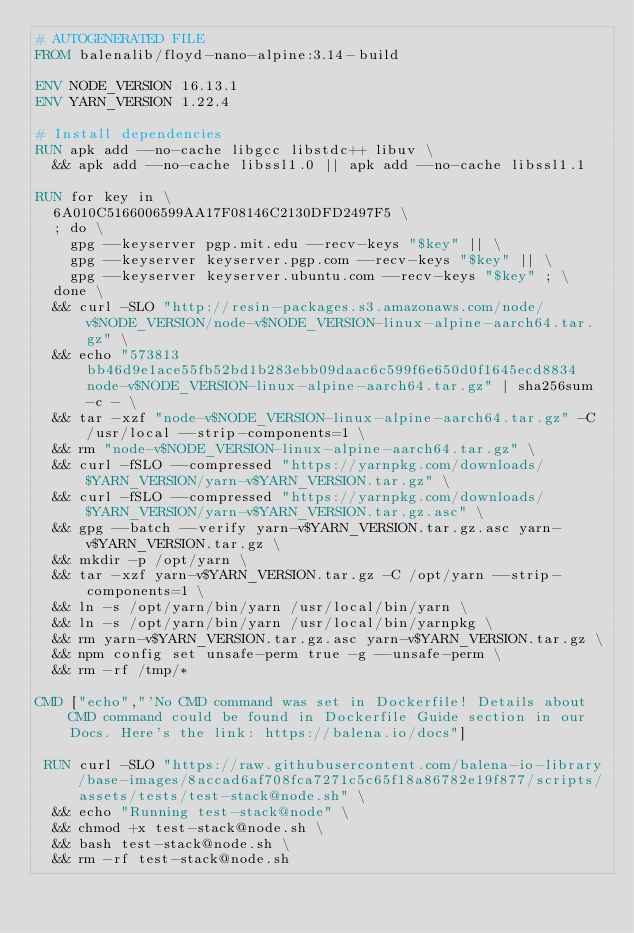<code> <loc_0><loc_0><loc_500><loc_500><_Dockerfile_># AUTOGENERATED FILE
FROM balenalib/floyd-nano-alpine:3.14-build

ENV NODE_VERSION 16.13.1
ENV YARN_VERSION 1.22.4

# Install dependencies
RUN apk add --no-cache libgcc libstdc++ libuv \
	&& apk add --no-cache libssl1.0 || apk add --no-cache libssl1.1

RUN for key in \
	6A010C5166006599AA17F08146C2130DFD2497F5 \
	; do \
		gpg --keyserver pgp.mit.edu --recv-keys "$key" || \
		gpg --keyserver keyserver.pgp.com --recv-keys "$key" || \
		gpg --keyserver keyserver.ubuntu.com --recv-keys "$key" ; \
	done \
	&& curl -SLO "http://resin-packages.s3.amazonaws.com/node/v$NODE_VERSION/node-v$NODE_VERSION-linux-alpine-aarch64.tar.gz" \
	&& echo "573813bb46d9e1ace55fb52bd1b283ebb09daac6c599f6e650d0f1645ecd8834  node-v$NODE_VERSION-linux-alpine-aarch64.tar.gz" | sha256sum -c - \
	&& tar -xzf "node-v$NODE_VERSION-linux-alpine-aarch64.tar.gz" -C /usr/local --strip-components=1 \
	&& rm "node-v$NODE_VERSION-linux-alpine-aarch64.tar.gz" \
	&& curl -fSLO --compressed "https://yarnpkg.com/downloads/$YARN_VERSION/yarn-v$YARN_VERSION.tar.gz" \
	&& curl -fSLO --compressed "https://yarnpkg.com/downloads/$YARN_VERSION/yarn-v$YARN_VERSION.tar.gz.asc" \
	&& gpg --batch --verify yarn-v$YARN_VERSION.tar.gz.asc yarn-v$YARN_VERSION.tar.gz \
	&& mkdir -p /opt/yarn \
	&& tar -xzf yarn-v$YARN_VERSION.tar.gz -C /opt/yarn --strip-components=1 \
	&& ln -s /opt/yarn/bin/yarn /usr/local/bin/yarn \
	&& ln -s /opt/yarn/bin/yarn /usr/local/bin/yarnpkg \
	&& rm yarn-v$YARN_VERSION.tar.gz.asc yarn-v$YARN_VERSION.tar.gz \
	&& npm config set unsafe-perm true -g --unsafe-perm \
	&& rm -rf /tmp/*

CMD ["echo","'No CMD command was set in Dockerfile! Details about CMD command could be found in Dockerfile Guide section in our Docs. Here's the link: https://balena.io/docs"]

 RUN curl -SLO "https://raw.githubusercontent.com/balena-io-library/base-images/8accad6af708fca7271c5c65f18a86782e19f877/scripts/assets/tests/test-stack@node.sh" \
  && echo "Running test-stack@node" \
  && chmod +x test-stack@node.sh \
  && bash test-stack@node.sh \
  && rm -rf test-stack@node.sh 
</code> 